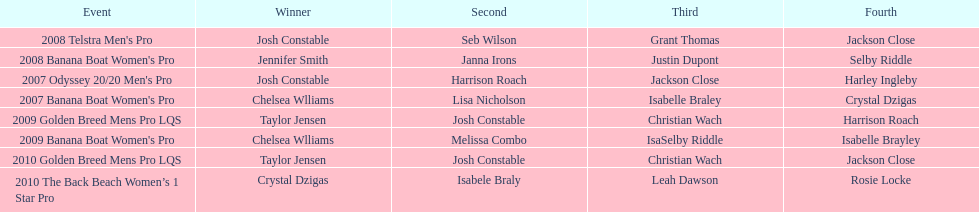At which event did taylor jensen first win? 2009 Golden Breed Mens Pro LQS. 